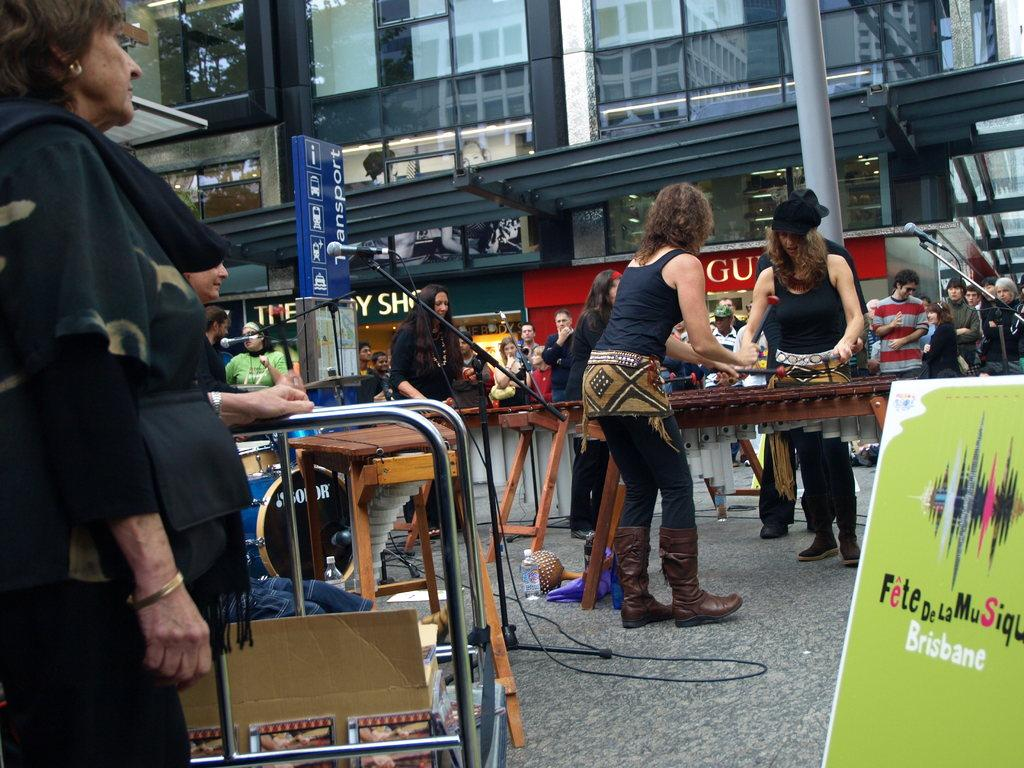What is the main object in the center of the image? There is a microphone and its stand in the center of the image. What type of furniture can be seen in the image? There are tables in the image. What else is present in the image besides the microphone and tables? There are objects in the image. What is on the right side of the image? There is a banner on the right side of the image. What can be seen in the background of the image? There are buildings visible in the background of the image. How does the family feel about the stomach ache in the image? There is no mention of a family or stomach ache in the image; it features a microphone, tables, objects, a banner, and buildings in the background. What channel is the image broadcasting on? The image is not a broadcast or video; it is a still photograph, so there is no channel associated with it. 